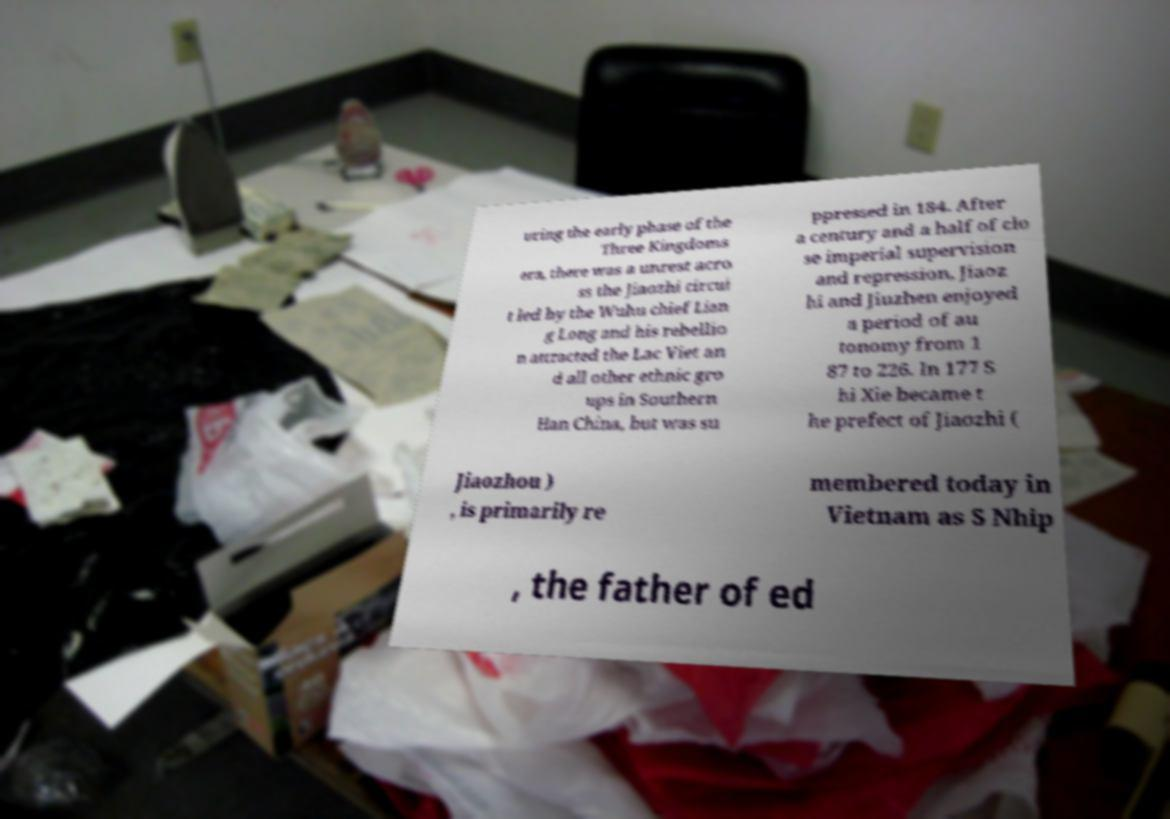Please read and relay the text visible in this image. What does it say? uring the early phase of the Three Kingdoms era, there was a unrest acro ss the Jiaozhi circui t led by the Wuhu chief Lian g Long and his rebellio n attracted the Lac Viet an d all other ethnic gro ups in Southern Han China, but was su ppressed in 184. After a century and a half of clo se imperial supervision and repression, Jiaoz hi and Jiuzhen enjoyed a period of au tonomy from 1 87 to 226. In 177 S hi Xie became t he prefect of Jiaozhi ( Jiaozhou ) , is primarily re membered today in Vietnam as S Nhip , the father of ed 